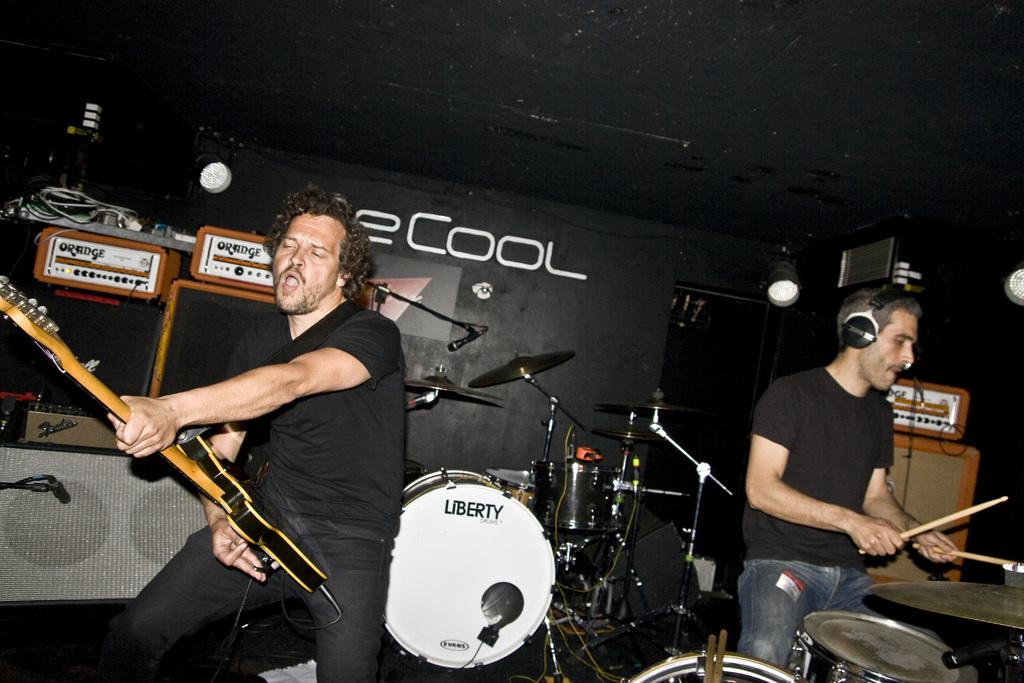How many people are in the image? There are two people in the image. What are the people doing in the image? One person is holding a guitar, and another person is playing a drum set. Can you describe the drum set setup in the image? There is a drum set in front of the person playing it, and another drum set is visible behind them. What is the person playing the drum set wearing? The person playing the drum set is wearing headphones. Can you see any smoke coming from the guitar in the image? There is no smoke present in the image; it features two people playing musical instruments, a guitar and a drum set. 